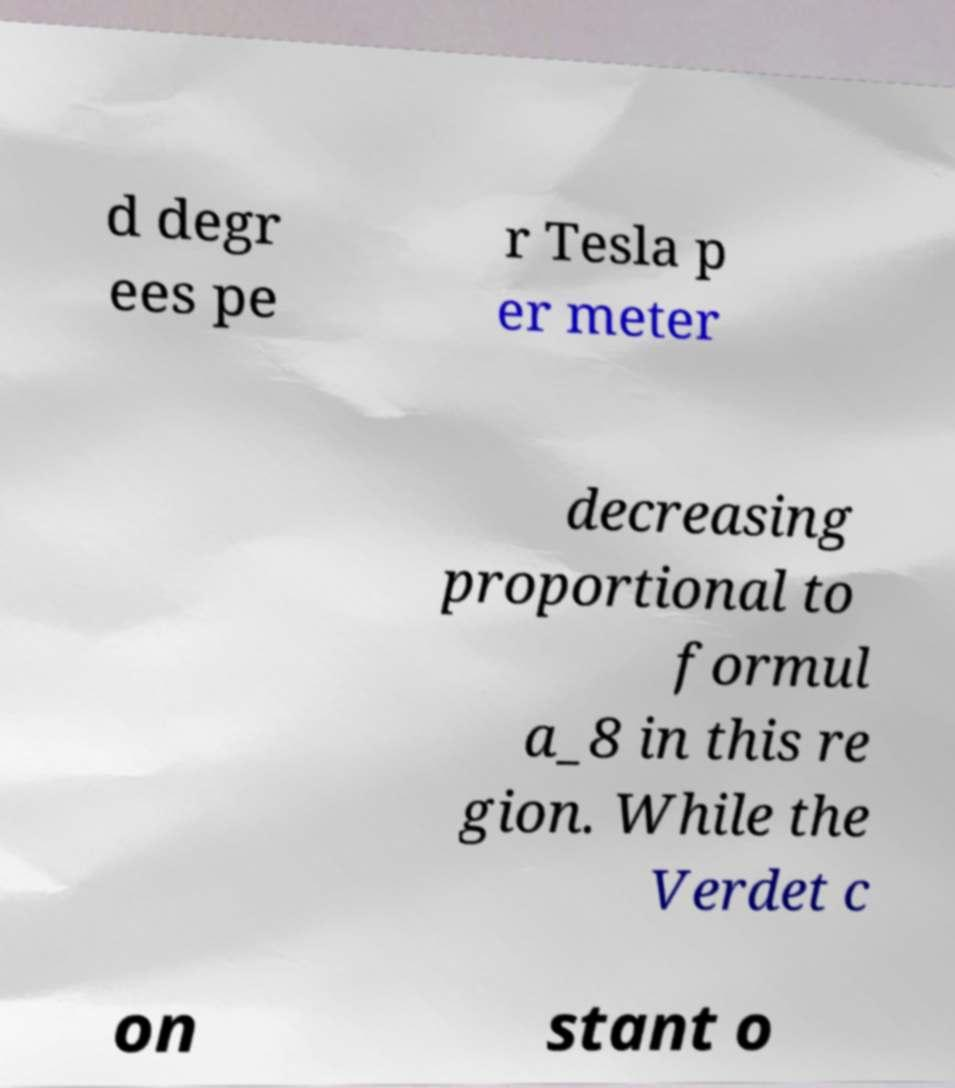For documentation purposes, I need the text within this image transcribed. Could you provide that? d degr ees pe r Tesla p er meter decreasing proportional to formul a_8 in this re gion. While the Verdet c on stant o 